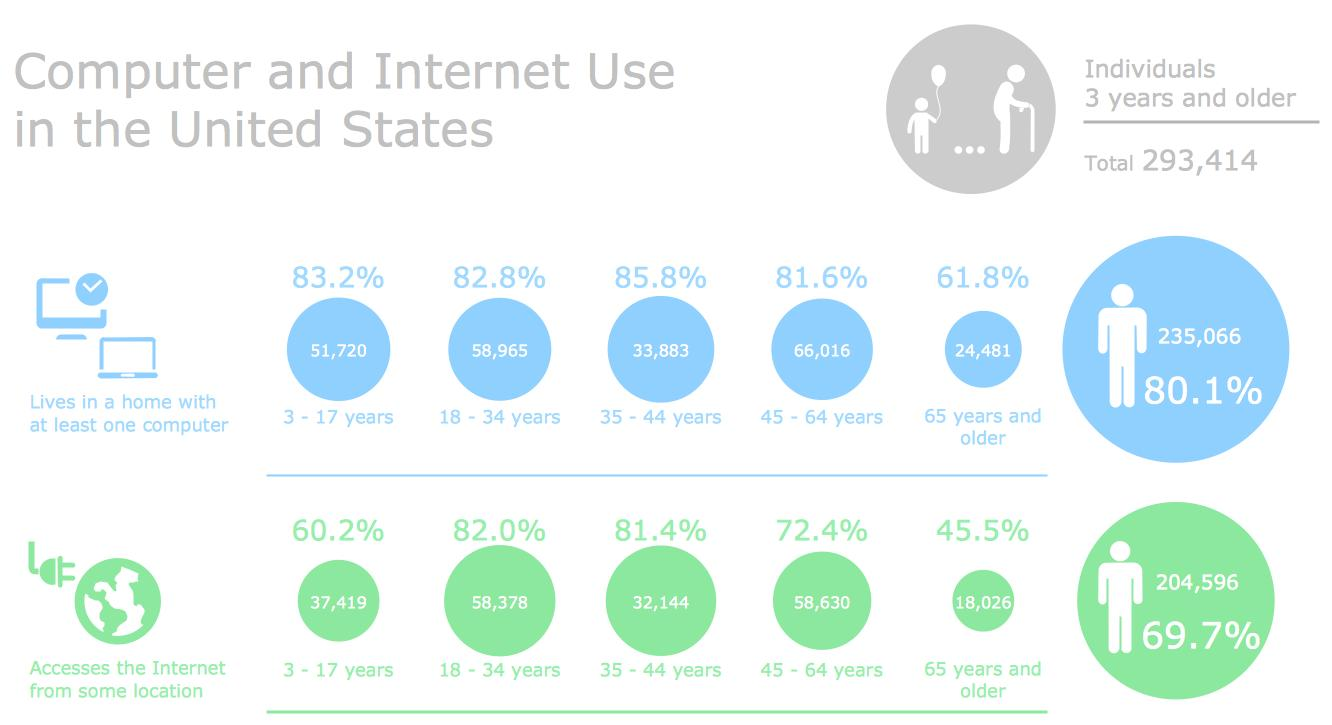Give some essential details in this illustration. According to the data, approximately 14,888 individuals under the age of 35 have a home computer but are unable to access the internet. According to the data, there are 24,481 senior citizens who own a computer at home. In 2018, it is estimated that 110,685 individuals under the age of 35 own a computer at home. According to statistics, out of the population below the age of 35, approximately 957,970 individuals have access to the internet. According to a recent survey, 45.5% of senior citizens have access to the internet from some location. 